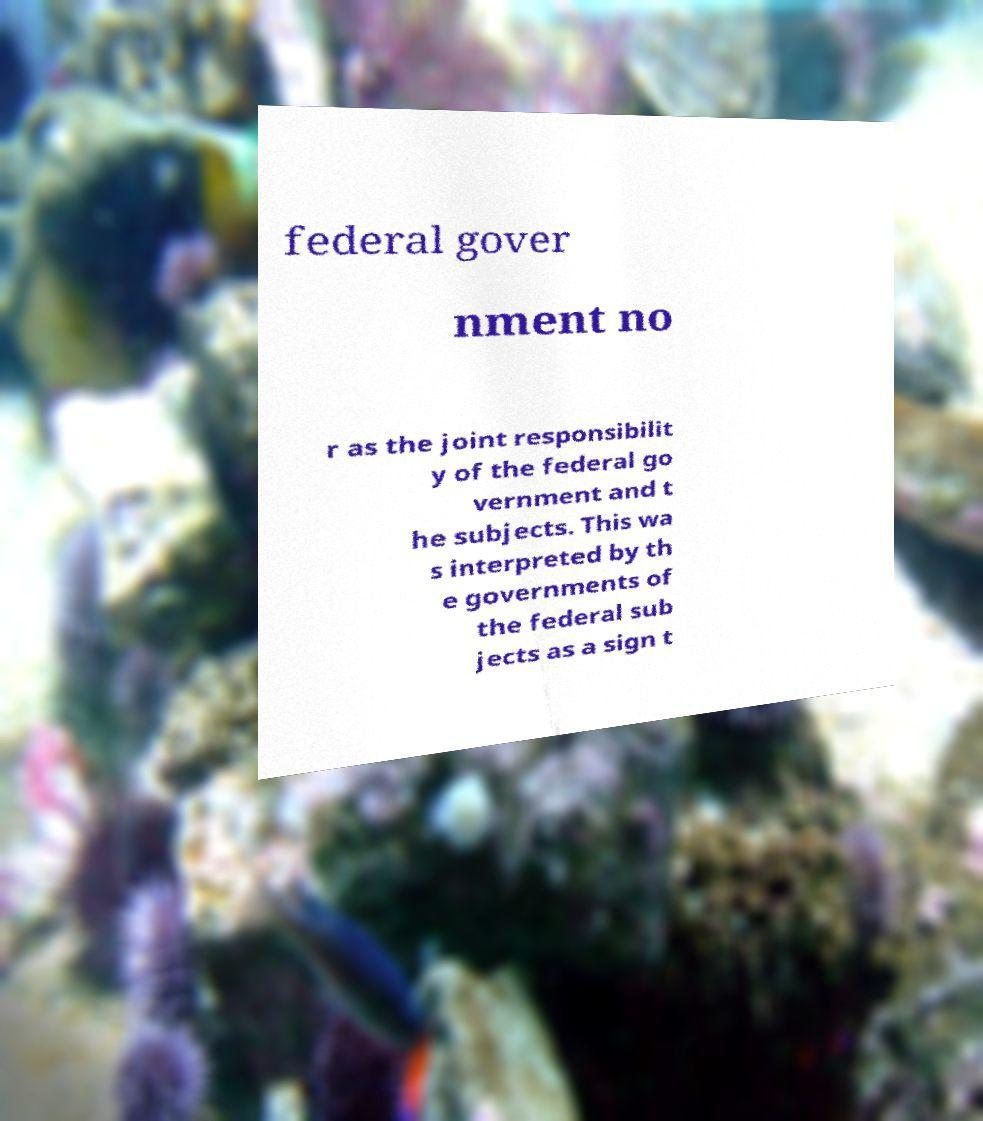There's text embedded in this image that I need extracted. Can you transcribe it verbatim? federal gover nment no r as the joint responsibilit y of the federal go vernment and t he subjects. This wa s interpreted by th e governments of the federal sub jects as a sign t 